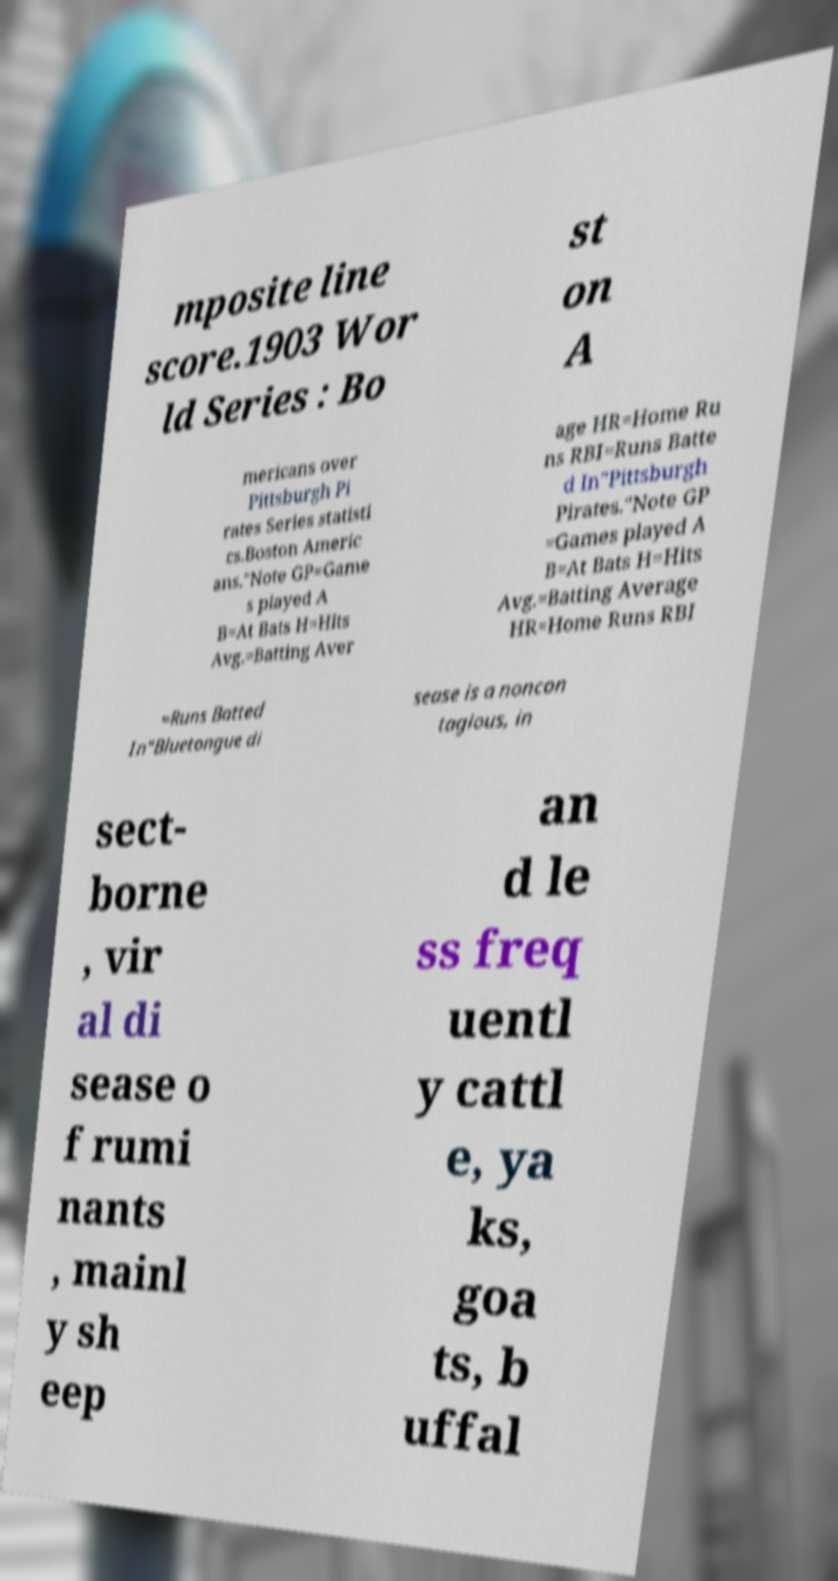Could you assist in decoding the text presented in this image and type it out clearly? mposite line score.1903 Wor ld Series : Bo st on A mericans over Pittsburgh Pi rates Series statisti cs.Boston Americ ans."Note GP=Game s played A B=At Bats H=Hits Avg.=Batting Aver age HR=Home Ru ns RBI=Runs Batte d In"Pittsburgh Pirates."Note GP =Games played A B=At Bats H=Hits Avg.=Batting Average HR=Home Runs RBI =Runs Batted In"Bluetongue di sease is a noncon tagious, in sect- borne , vir al di sease o f rumi nants , mainl y sh eep an d le ss freq uentl y cattl e, ya ks, goa ts, b uffal 